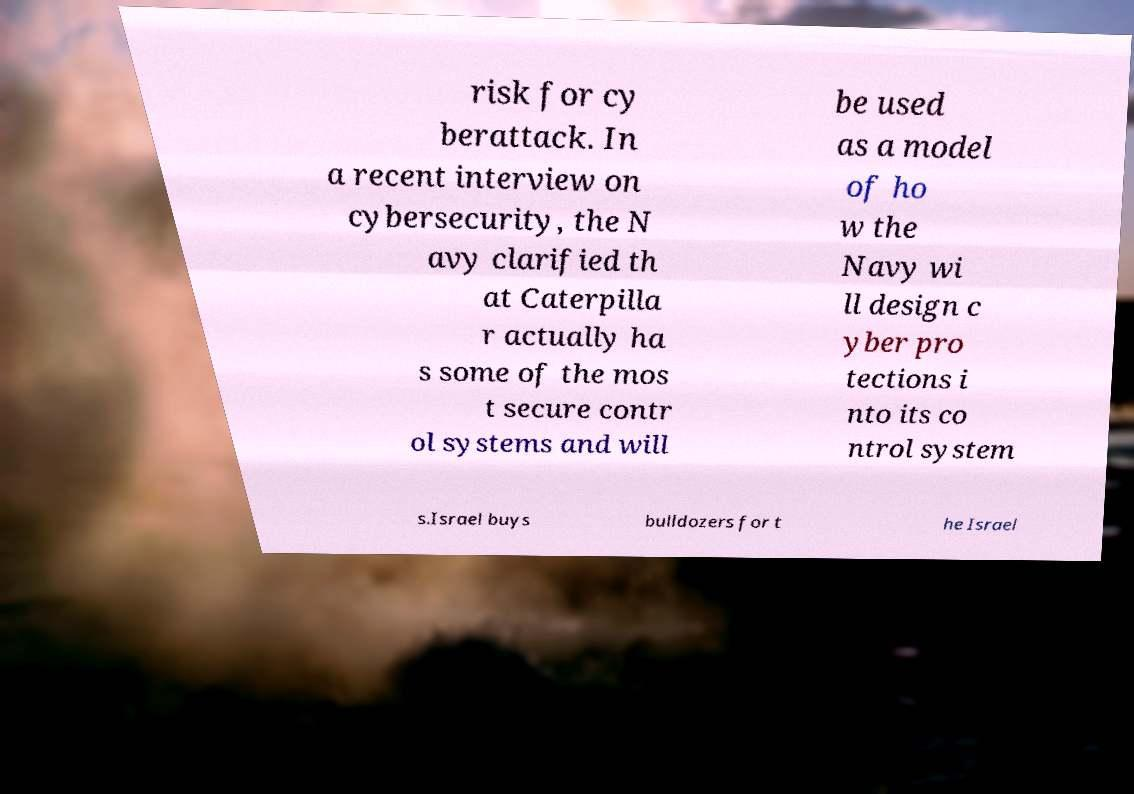Could you assist in decoding the text presented in this image and type it out clearly? risk for cy berattack. In a recent interview on cybersecurity, the N avy clarified th at Caterpilla r actually ha s some of the mos t secure contr ol systems and will be used as a model of ho w the Navy wi ll design c yber pro tections i nto its co ntrol system s.Israel buys bulldozers for t he Israel 